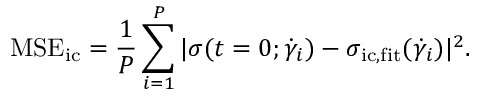Convert formula to latex. <formula><loc_0><loc_0><loc_500><loc_500>M S E _ { \mathrm { i c } } = \frac { 1 } { P } \sum _ { i = 1 } ^ { P } | \sigma ( t = 0 ; \dot { \gamma } _ { i } ) - \sigma _ { i c , f i t } ( \dot { \gamma } _ { i } ) | ^ { 2 } .</formula> 